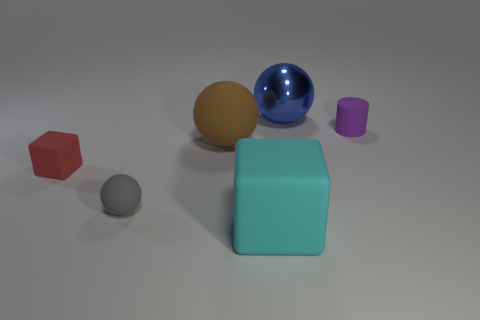Add 1 rubber objects. How many objects exist? 7 Subtract all blocks. How many objects are left? 4 Add 5 big green matte cylinders. How many big green matte cylinders exist? 5 Subtract 0 purple cubes. How many objects are left? 6 Subtract all cyan metal balls. Subtract all blue metallic spheres. How many objects are left? 5 Add 2 cyan things. How many cyan things are left? 3 